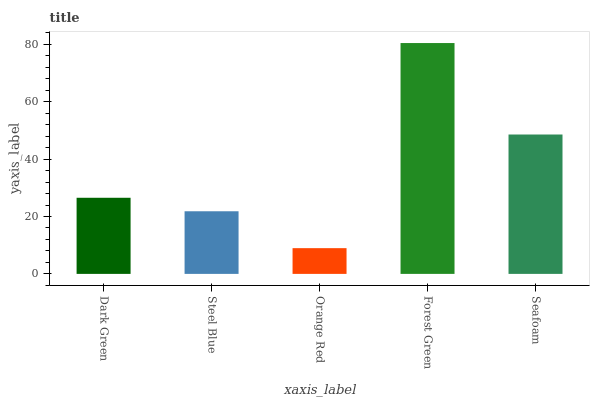Is Orange Red the minimum?
Answer yes or no. Yes. Is Forest Green the maximum?
Answer yes or no. Yes. Is Steel Blue the minimum?
Answer yes or no. No. Is Steel Blue the maximum?
Answer yes or no. No. Is Dark Green greater than Steel Blue?
Answer yes or no. Yes. Is Steel Blue less than Dark Green?
Answer yes or no. Yes. Is Steel Blue greater than Dark Green?
Answer yes or no. No. Is Dark Green less than Steel Blue?
Answer yes or no. No. Is Dark Green the high median?
Answer yes or no. Yes. Is Dark Green the low median?
Answer yes or no. Yes. Is Seafoam the high median?
Answer yes or no. No. Is Seafoam the low median?
Answer yes or no. No. 